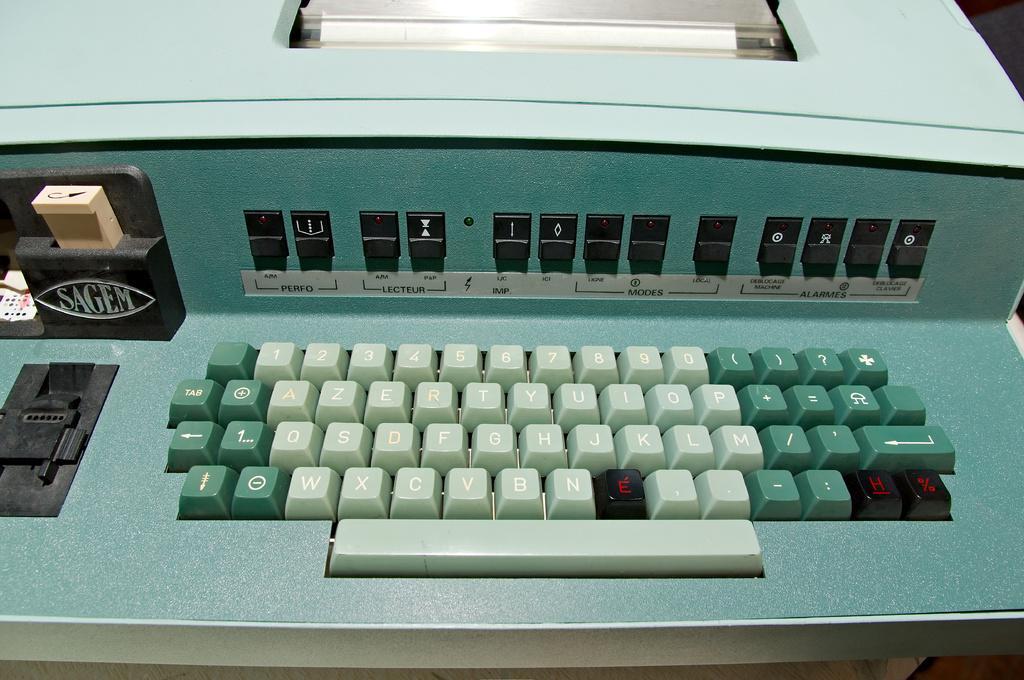Could you give a brief overview of what you see in this image? In this picture we can observe a typing machine. We can observe green and pale green color keys. This machine is in blue and green color. We can observe black color keys on this machine. 